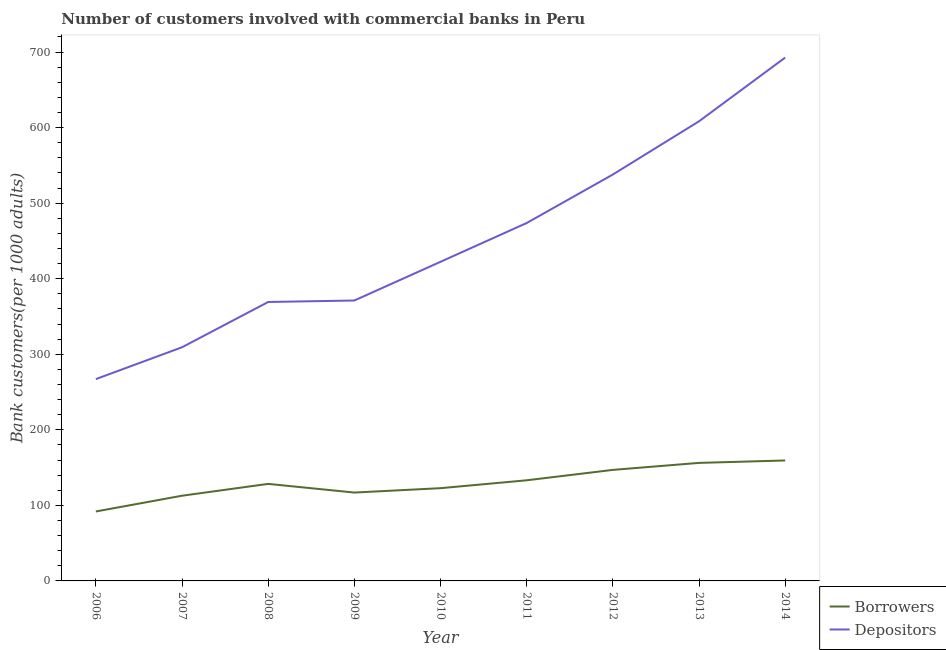How many different coloured lines are there?
Your answer should be very brief. 2. What is the number of borrowers in 2009?
Ensure brevity in your answer.  116.95. Across all years, what is the maximum number of borrowers?
Provide a short and direct response. 159.42. Across all years, what is the minimum number of borrowers?
Your response must be concise. 91.92. In which year was the number of depositors maximum?
Ensure brevity in your answer.  2014. What is the total number of depositors in the graph?
Provide a short and direct response. 4051.47. What is the difference between the number of borrowers in 2008 and that in 2009?
Keep it short and to the point. 11.47. What is the difference between the number of depositors in 2006 and the number of borrowers in 2012?
Keep it short and to the point. 120.16. What is the average number of borrowers per year?
Your answer should be compact. 129.84. In the year 2012, what is the difference between the number of borrowers and number of depositors?
Your answer should be compact. -390.93. In how many years, is the number of borrowers greater than 560?
Ensure brevity in your answer.  0. What is the ratio of the number of depositors in 2006 to that in 2014?
Provide a succinct answer. 0.39. What is the difference between the highest and the second highest number of borrowers?
Provide a short and direct response. 3.21. What is the difference between the highest and the lowest number of depositors?
Make the answer very short. 425.54. Is the sum of the number of borrowers in 2011 and 2013 greater than the maximum number of depositors across all years?
Provide a succinct answer. No. How many lines are there?
Your answer should be very brief. 2. How many years are there in the graph?
Offer a very short reply. 9. What is the difference between two consecutive major ticks on the Y-axis?
Offer a terse response. 100. Does the graph contain any zero values?
Your response must be concise. No. Where does the legend appear in the graph?
Your response must be concise. Bottom right. How many legend labels are there?
Provide a short and direct response. 2. What is the title of the graph?
Provide a succinct answer. Number of customers involved with commercial banks in Peru. Does "Lower secondary education" appear as one of the legend labels in the graph?
Your response must be concise. No. What is the label or title of the X-axis?
Give a very brief answer. Year. What is the label or title of the Y-axis?
Keep it short and to the point. Bank customers(per 1000 adults). What is the Bank customers(per 1000 adults) of Borrowers in 2006?
Your answer should be very brief. 91.92. What is the Bank customers(per 1000 adults) of Depositors in 2006?
Make the answer very short. 267.1. What is the Bank customers(per 1000 adults) of Borrowers in 2007?
Offer a terse response. 112.76. What is the Bank customers(per 1000 adults) of Depositors in 2007?
Offer a terse response. 309.23. What is the Bank customers(per 1000 adults) in Borrowers in 2008?
Give a very brief answer. 128.42. What is the Bank customers(per 1000 adults) in Depositors in 2008?
Your answer should be very brief. 369.17. What is the Bank customers(per 1000 adults) of Borrowers in 2009?
Offer a very short reply. 116.95. What is the Bank customers(per 1000 adults) of Depositors in 2009?
Your answer should be very brief. 371.13. What is the Bank customers(per 1000 adults) of Borrowers in 2010?
Offer a very short reply. 122.75. What is the Bank customers(per 1000 adults) of Depositors in 2010?
Ensure brevity in your answer.  422.34. What is the Bank customers(per 1000 adults) in Borrowers in 2011?
Offer a very short reply. 133.19. What is the Bank customers(per 1000 adults) in Depositors in 2011?
Your answer should be compact. 473.69. What is the Bank customers(per 1000 adults) in Borrowers in 2012?
Provide a short and direct response. 146.94. What is the Bank customers(per 1000 adults) of Depositors in 2012?
Your response must be concise. 537.87. What is the Bank customers(per 1000 adults) of Borrowers in 2013?
Offer a terse response. 156.21. What is the Bank customers(per 1000 adults) of Depositors in 2013?
Offer a terse response. 608.29. What is the Bank customers(per 1000 adults) of Borrowers in 2014?
Make the answer very short. 159.42. What is the Bank customers(per 1000 adults) of Depositors in 2014?
Provide a succinct answer. 692.64. Across all years, what is the maximum Bank customers(per 1000 adults) of Borrowers?
Provide a succinct answer. 159.42. Across all years, what is the maximum Bank customers(per 1000 adults) in Depositors?
Ensure brevity in your answer.  692.64. Across all years, what is the minimum Bank customers(per 1000 adults) in Borrowers?
Your answer should be very brief. 91.92. Across all years, what is the minimum Bank customers(per 1000 adults) of Depositors?
Make the answer very short. 267.1. What is the total Bank customers(per 1000 adults) in Borrowers in the graph?
Keep it short and to the point. 1168.57. What is the total Bank customers(per 1000 adults) in Depositors in the graph?
Your answer should be compact. 4051.47. What is the difference between the Bank customers(per 1000 adults) of Borrowers in 2006 and that in 2007?
Offer a terse response. -20.84. What is the difference between the Bank customers(per 1000 adults) in Depositors in 2006 and that in 2007?
Give a very brief answer. -42.13. What is the difference between the Bank customers(per 1000 adults) in Borrowers in 2006 and that in 2008?
Your answer should be compact. -36.5. What is the difference between the Bank customers(per 1000 adults) of Depositors in 2006 and that in 2008?
Your answer should be compact. -102.07. What is the difference between the Bank customers(per 1000 adults) in Borrowers in 2006 and that in 2009?
Keep it short and to the point. -25.03. What is the difference between the Bank customers(per 1000 adults) of Depositors in 2006 and that in 2009?
Provide a succinct answer. -104.03. What is the difference between the Bank customers(per 1000 adults) in Borrowers in 2006 and that in 2010?
Ensure brevity in your answer.  -30.83. What is the difference between the Bank customers(per 1000 adults) in Depositors in 2006 and that in 2010?
Keep it short and to the point. -155.24. What is the difference between the Bank customers(per 1000 adults) of Borrowers in 2006 and that in 2011?
Your answer should be compact. -41.26. What is the difference between the Bank customers(per 1000 adults) of Depositors in 2006 and that in 2011?
Your response must be concise. -206.59. What is the difference between the Bank customers(per 1000 adults) in Borrowers in 2006 and that in 2012?
Provide a succinct answer. -55.02. What is the difference between the Bank customers(per 1000 adults) of Depositors in 2006 and that in 2012?
Ensure brevity in your answer.  -270.77. What is the difference between the Bank customers(per 1000 adults) of Borrowers in 2006 and that in 2013?
Your answer should be compact. -64.29. What is the difference between the Bank customers(per 1000 adults) in Depositors in 2006 and that in 2013?
Offer a terse response. -341.19. What is the difference between the Bank customers(per 1000 adults) in Borrowers in 2006 and that in 2014?
Provide a succinct answer. -67.49. What is the difference between the Bank customers(per 1000 adults) in Depositors in 2006 and that in 2014?
Your response must be concise. -425.54. What is the difference between the Bank customers(per 1000 adults) in Borrowers in 2007 and that in 2008?
Provide a short and direct response. -15.66. What is the difference between the Bank customers(per 1000 adults) in Depositors in 2007 and that in 2008?
Your answer should be compact. -59.93. What is the difference between the Bank customers(per 1000 adults) of Borrowers in 2007 and that in 2009?
Your answer should be compact. -4.19. What is the difference between the Bank customers(per 1000 adults) in Depositors in 2007 and that in 2009?
Provide a succinct answer. -61.9. What is the difference between the Bank customers(per 1000 adults) of Borrowers in 2007 and that in 2010?
Offer a very short reply. -9.99. What is the difference between the Bank customers(per 1000 adults) of Depositors in 2007 and that in 2010?
Make the answer very short. -113.11. What is the difference between the Bank customers(per 1000 adults) in Borrowers in 2007 and that in 2011?
Make the answer very short. -20.42. What is the difference between the Bank customers(per 1000 adults) of Depositors in 2007 and that in 2011?
Offer a very short reply. -164.46. What is the difference between the Bank customers(per 1000 adults) in Borrowers in 2007 and that in 2012?
Ensure brevity in your answer.  -34.18. What is the difference between the Bank customers(per 1000 adults) in Depositors in 2007 and that in 2012?
Offer a terse response. -228.64. What is the difference between the Bank customers(per 1000 adults) of Borrowers in 2007 and that in 2013?
Give a very brief answer. -43.45. What is the difference between the Bank customers(per 1000 adults) of Depositors in 2007 and that in 2013?
Offer a terse response. -299.06. What is the difference between the Bank customers(per 1000 adults) in Borrowers in 2007 and that in 2014?
Offer a very short reply. -46.65. What is the difference between the Bank customers(per 1000 adults) of Depositors in 2007 and that in 2014?
Ensure brevity in your answer.  -383.41. What is the difference between the Bank customers(per 1000 adults) of Borrowers in 2008 and that in 2009?
Your answer should be compact. 11.47. What is the difference between the Bank customers(per 1000 adults) of Depositors in 2008 and that in 2009?
Offer a terse response. -1.97. What is the difference between the Bank customers(per 1000 adults) of Borrowers in 2008 and that in 2010?
Offer a terse response. 5.67. What is the difference between the Bank customers(per 1000 adults) of Depositors in 2008 and that in 2010?
Make the answer very short. -53.18. What is the difference between the Bank customers(per 1000 adults) in Borrowers in 2008 and that in 2011?
Provide a succinct answer. -4.77. What is the difference between the Bank customers(per 1000 adults) of Depositors in 2008 and that in 2011?
Make the answer very short. -104.52. What is the difference between the Bank customers(per 1000 adults) of Borrowers in 2008 and that in 2012?
Your answer should be compact. -18.52. What is the difference between the Bank customers(per 1000 adults) of Depositors in 2008 and that in 2012?
Give a very brief answer. -168.7. What is the difference between the Bank customers(per 1000 adults) of Borrowers in 2008 and that in 2013?
Give a very brief answer. -27.79. What is the difference between the Bank customers(per 1000 adults) in Depositors in 2008 and that in 2013?
Your answer should be very brief. -239.12. What is the difference between the Bank customers(per 1000 adults) of Borrowers in 2008 and that in 2014?
Your answer should be compact. -31. What is the difference between the Bank customers(per 1000 adults) of Depositors in 2008 and that in 2014?
Your answer should be compact. -323.48. What is the difference between the Bank customers(per 1000 adults) of Borrowers in 2009 and that in 2010?
Make the answer very short. -5.8. What is the difference between the Bank customers(per 1000 adults) in Depositors in 2009 and that in 2010?
Your answer should be compact. -51.21. What is the difference between the Bank customers(per 1000 adults) in Borrowers in 2009 and that in 2011?
Your response must be concise. -16.24. What is the difference between the Bank customers(per 1000 adults) of Depositors in 2009 and that in 2011?
Make the answer very short. -102.56. What is the difference between the Bank customers(per 1000 adults) in Borrowers in 2009 and that in 2012?
Ensure brevity in your answer.  -29.99. What is the difference between the Bank customers(per 1000 adults) in Depositors in 2009 and that in 2012?
Your answer should be compact. -166.74. What is the difference between the Bank customers(per 1000 adults) in Borrowers in 2009 and that in 2013?
Keep it short and to the point. -39.26. What is the difference between the Bank customers(per 1000 adults) of Depositors in 2009 and that in 2013?
Your response must be concise. -237.16. What is the difference between the Bank customers(per 1000 adults) in Borrowers in 2009 and that in 2014?
Offer a very short reply. -42.47. What is the difference between the Bank customers(per 1000 adults) of Depositors in 2009 and that in 2014?
Make the answer very short. -321.51. What is the difference between the Bank customers(per 1000 adults) in Borrowers in 2010 and that in 2011?
Your answer should be very brief. -10.43. What is the difference between the Bank customers(per 1000 adults) of Depositors in 2010 and that in 2011?
Keep it short and to the point. -51.35. What is the difference between the Bank customers(per 1000 adults) of Borrowers in 2010 and that in 2012?
Make the answer very short. -24.19. What is the difference between the Bank customers(per 1000 adults) in Depositors in 2010 and that in 2012?
Provide a succinct answer. -115.53. What is the difference between the Bank customers(per 1000 adults) of Borrowers in 2010 and that in 2013?
Offer a very short reply. -33.46. What is the difference between the Bank customers(per 1000 adults) in Depositors in 2010 and that in 2013?
Make the answer very short. -185.95. What is the difference between the Bank customers(per 1000 adults) in Borrowers in 2010 and that in 2014?
Ensure brevity in your answer.  -36.66. What is the difference between the Bank customers(per 1000 adults) in Depositors in 2010 and that in 2014?
Provide a short and direct response. -270.3. What is the difference between the Bank customers(per 1000 adults) in Borrowers in 2011 and that in 2012?
Your response must be concise. -13.75. What is the difference between the Bank customers(per 1000 adults) in Depositors in 2011 and that in 2012?
Make the answer very short. -64.18. What is the difference between the Bank customers(per 1000 adults) in Borrowers in 2011 and that in 2013?
Give a very brief answer. -23.02. What is the difference between the Bank customers(per 1000 adults) in Depositors in 2011 and that in 2013?
Give a very brief answer. -134.6. What is the difference between the Bank customers(per 1000 adults) in Borrowers in 2011 and that in 2014?
Make the answer very short. -26.23. What is the difference between the Bank customers(per 1000 adults) of Depositors in 2011 and that in 2014?
Your response must be concise. -218.95. What is the difference between the Bank customers(per 1000 adults) of Borrowers in 2012 and that in 2013?
Ensure brevity in your answer.  -9.27. What is the difference between the Bank customers(per 1000 adults) in Depositors in 2012 and that in 2013?
Your answer should be very brief. -70.42. What is the difference between the Bank customers(per 1000 adults) in Borrowers in 2012 and that in 2014?
Provide a succinct answer. -12.48. What is the difference between the Bank customers(per 1000 adults) of Depositors in 2012 and that in 2014?
Keep it short and to the point. -154.77. What is the difference between the Bank customers(per 1000 adults) of Borrowers in 2013 and that in 2014?
Keep it short and to the point. -3.21. What is the difference between the Bank customers(per 1000 adults) in Depositors in 2013 and that in 2014?
Your answer should be very brief. -84.35. What is the difference between the Bank customers(per 1000 adults) of Borrowers in 2006 and the Bank customers(per 1000 adults) of Depositors in 2007?
Ensure brevity in your answer.  -217.31. What is the difference between the Bank customers(per 1000 adults) in Borrowers in 2006 and the Bank customers(per 1000 adults) in Depositors in 2008?
Your answer should be compact. -277.24. What is the difference between the Bank customers(per 1000 adults) of Borrowers in 2006 and the Bank customers(per 1000 adults) of Depositors in 2009?
Keep it short and to the point. -279.21. What is the difference between the Bank customers(per 1000 adults) in Borrowers in 2006 and the Bank customers(per 1000 adults) in Depositors in 2010?
Your answer should be very brief. -330.42. What is the difference between the Bank customers(per 1000 adults) in Borrowers in 2006 and the Bank customers(per 1000 adults) in Depositors in 2011?
Keep it short and to the point. -381.76. What is the difference between the Bank customers(per 1000 adults) of Borrowers in 2006 and the Bank customers(per 1000 adults) of Depositors in 2012?
Ensure brevity in your answer.  -445.95. What is the difference between the Bank customers(per 1000 adults) of Borrowers in 2006 and the Bank customers(per 1000 adults) of Depositors in 2013?
Offer a very short reply. -516.37. What is the difference between the Bank customers(per 1000 adults) of Borrowers in 2006 and the Bank customers(per 1000 adults) of Depositors in 2014?
Make the answer very short. -600.72. What is the difference between the Bank customers(per 1000 adults) of Borrowers in 2007 and the Bank customers(per 1000 adults) of Depositors in 2008?
Your response must be concise. -256.4. What is the difference between the Bank customers(per 1000 adults) in Borrowers in 2007 and the Bank customers(per 1000 adults) in Depositors in 2009?
Your answer should be very brief. -258.37. What is the difference between the Bank customers(per 1000 adults) of Borrowers in 2007 and the Bank customers(per 1000 adults) of Depositors in 2010?
Give a very brief answer. -309.58. What is the difference between the Bank customers(per 1000 adults) in Borrowers in 2007 and the Bank customers(per 1000 adults) in Depositors in 2011?
Provide a succinct answer. -360.93. What is the difference between the Bank customers(per 1000 adults) in Borrowers in 2007 and the Bank customers(per 1000 adults) in Depositors in 2012?
Your response must be concise. -425.11. What is the difference between the Bank customers(per 1000 adults) of Borrowers in 2007 and the Bank customers(per 1000 adults) of Depositors in 2013?
Provide a short and direct response. -495.53. What is the difference between the Bank customers(per 1000 adults) in Borrowers in 2007 and the Bank customers(per 1000 adults) in Depositors in 2014?
Offer a very short reply. -579.88. What is the difference between the Bank customers(per 1000 adults) in Borrowers in 2008 and the Bank customers(per 1000 adults) in Depositors in 2009?
Your answer should be compact. -242.71. What is the difference between the Bank customers(per 1000 adults) in Borrowers in 2008 and the Bank customers(per 1000 adults) in Depositors in 2010?
Provide a succinct answer. -293.92. What is the difference between the Bank customers(per 1000 adults) of Borrowers in 2008 and the Bank customers(per 1000 adults) of Depositors in 2011?
Provide a short and direct response. -345.27. What is the difference between the Bank customers(per 1000 adults) in Borrowers in 2008 and the Bank customers(per 1000 adults) in Depositors in 2012?
Provide a succinct answer. -409.45. What is the difference between the Bank customers(per 1000 adults) in Borrowers in 2008 and the Bank customers(per 1000 adults) in Depositors in 2013?
Provide a short and direct response. -479.87. What is the difference between the Bank customers(per 1000 adults) in Borrowers in 2008 and the Bank customers(per 1000 adults) in Depositors in 2014?
Keep it short and to the point. -564.22. What is the difference between the Bank customers(per 1000 adults) in Borrowers in 2009 and the Bank customers(per 1000 adults) in Depositors in 2010?
Provide a short and direct response. -305.39. What is the difference between the Bank customers(per 1000 adults) in Borrowers in 2009 and the Bank customers(per 1000 adults) in Depositors in 2011?
Your answer should be compact. -356.74. What is the difference between the Bank customers(per 1000 adults) in Borrowers in 2009 and the Bank customers(per 1000 adults) in Depositors in 2012?
Ensure brevity in your answer.  -420.92. What is the difference between the Bank customers(per 1000 adults) in Borrowers in 2009 and the Bank customers(per 1000 adults) in Depositors in 2013?
Ensure brevity in your answer.  -491.34. What is the difference between the Bank customers(per 1000 adults) in Borrowers in 2009 and the Bank customers(per 1000 adults) in Depositors in 2014?
Offer a terse response. -575.69. What is the difference between the Bank customers(per 1000 adults) in Borrowers in 2010 and the Bank customers(per 1000 adults) in Depositors in 2011?
Provide a short and direct response. -350.94. What is the difference between the Bank customers(per 1000 adults) of Borrowers in 2010 and the Bank customers(per 1000 adults) of Depositors in 2012?
Make the answer very short. -415.12. What is the difference between the Bank customers(per 1000 adults) of Borrowers in 2010 and the Bank customers(per 1000 adults) of Depositors in 2013?
Offer a terse response. -485.54. What is the difference between the Bank customers(per 1000 adults) in Borrowers in 2010 and the Bank customers(per 1000 adults) in Depositors in 2014?
Your answer should be compact. -569.89. What is the difference between the Bank customers(per 1000 adults) in Borrowers in 2011 and the Bank customers(per 1000 adults) in Depositors in 2012?
Ensure brevity in your answer.  -404.68. What is the difference between the Bank customers(per 1000 adults) in Borrowers in 2011 and the Bank customers(per 1000 adults) in Depositors in 2013?
Provide a succinct answer. -475.1. What is the difference between the Bank customers(per 1000 adults) in Borrowers in 2011 and the Bank customers(per 1000 adults) in Depositors in 2014?
Keep it short and to the point. -559.46. What is the difference between the Bank customers(per 1000 adults) of Borrowers in 2012 and the Bank customers(per 1000 adults) of Depositors in 2013?
Keep it short and to the point. -461.35. What is the difference between the Bank customers(per 1000 adults) of Borrowers in 2012 and the Bank customers(per 1000 adults) of Depositors in 2014?
Your response must be concise. -545.7. What is the difference between the Bank customers(per 1000 adults) of Borrowers in 2013 and the Bank customers(per 1000 adults) of Depositors in 2014?
Make the answer very short. -536.43. What is the average Bank customers(per 1000 adults) of Borrowers per year?
Offer a terse response. 129.84. What is the average Bank customers(per 1000 adults) in Depositors per year?
Your answer should be compact. 450.16. In the year 2006, what is the difference between the Bank customers(per 1000 adults) of Borrowers and Bank customers(per 1000 adults) of Depositors?
Make the answer very short. -175.18. In the year 2007, what is the difference between the Bank customers(per 1000 adults) of Borrowers and Bank customers(per 1000 adults) of Depositors?
Your answer should be very brief. -196.47. In the year 2008, what is the difference between the Bank customers(per 1000 adults) in Borrowers and Bank customers(per 1000 adults) in Depositors?
Ensure brevity in your answer.  -240.75. In the year 2009, what is the difference between the Bank customers(per 1000 adults) of Borrowers and Bank customers(per 1000 adults) of Depositors?
Offer a terse response. -254.18. In the year 2010, what is the difference between the Bank customers(per 1000 adults) in Borrowers and Bank customers(per 1000 adults) in Depositors?
Your answer should be very brief. -299.59. In the year 2011, what is the difference between the Bank customers(per 1000 adults) in Borrowers and Bank customers(per 1000 adults) in Depositors?
Give a very brief answer. -340.5. In the year 2012, what is the difference between the Bank customers(per 1000 adults) in Borrowers and Bank customers(per 1000 adults) in Depositors?
Your response must be concise. -390.93. In the year 2013, what is the difference between the Bank customers(per 1000 adults) in Borrowers and Bank customers(per 1000 adults) in Depositors?
Make the answer very short. -452.08. In the year 2014, what is the difference between the Bank customers(per 1000 adults) of Borrowers and Bank customers(per 1000 adults) of Depositors?
Provide a succinct answer. -533.23. What is the ratio of the Bank customers(per 1000 adults) of Borrowers in 2006 to that in 2007?
Provide a short and direct response. 0.82. What is the ratio of the Bank customers(per 1000 adults) of Depositors in 2006 to that in 2007?
Your answer should be very brief. 0.86. What is the ratio of the Bank customers(per 1000 adults) in Borrowers in 2006 to that in 2008?
Give a very brief answer. 0.72. What is the ratio of the Bank customers(per 1000 adults) of Depositors in 2006 to that in 2008?
Offer a terse response. 0.72. What is the ratio of the Bank customers(per 1000 adults) of Borrowers in 2006 to that in 2009?
Keep it short and to the point. 0.79. What is the ratio of the Bank customers(per 1000 adults) in Depositors in 2006 to that in 2009?
Provide a succinct answer. 0.72. What is the ratio of the Bank customers(per 1000 adults) of Borrowers in 2006 to that in 2010?
Your answer should be very brief. 0.75. What is the ratio of the Bank customers(per 1000 adults) in Depositors in 2006 to that in 2010?
Give a very brief answer. 0.63. What is the ratio of the Bank customers(per 1000 adults) of Borrowers in 2006 to that in 2011?
Give a very brief answer. 0.69. What is the ratio of the Bank customers(per 1000 adults) in Depositors in 2006 to that in 2011?
Ensure brevity in your answer.  0.56. What is the ratio of the Bank customers(per 1000 adults) of Borrowers in 2006 to that in 2012?
Provide a succinct answer. 0.63. What is the ratio of the Bank customers(per 1000 adults) in Depositors in 2006 to that in 2012?
Your response must be concise. 0.5. What is the ratio of the Bank customers(per 1000 adults) of Borrowers in 2006 to that in 2013?
Your answer should be compact. 0.59. What is the ratio of the Bank customers(per 1000 adults) of Depositors in 2006 to that in 2013?
Provide a short and direct response. 0.44. What is the ratio of the Bank customers(per 1000 adults) in Borrowers in 2006 to that in 2014?
Give a very brief answer. 0.58. What is the ratio of the Bank customers(per 1000 adults) in Depositors in 2006 to that in 2014?
Provide a short and direct response. 0.39. What is the ratio of the Bank customers(per 1000 adults) in Borrowers in 2007 to that in 2008?
Provide a succinct answer. 0.88. What is the ratio of the Bank customers(per 1000 adults) in Depositors in 2007 to that in 2008?
Keep it short and to the point. 0.84. What is the ratio of the Bank customers(per 1000 adults) of Borrowers in 2007 to that in 2009?
Ensure brevity in your answer.  0.96. What is the ratio of the Bank customers(per 1000 adults) of Depositors in 2007 to that in 2009?
Ensure brevity in your answer.  0.83. What is the ratio of the Bank customers(per 1000 adults) of Borrowers in 2007 to that in 2010?
Give a very brief answer. 0.92. What is the ratio of the Bank customers(per 1000 adults) of Depositors in 2007 to that in 2010?
Offer a very short reply. 0.73. What is the ratio of the Bank customers(per 1000 adults) in Borrowers in 2007 to that in 2011?
Your answer should be very brief. 0.85. What is the ratio of the Bank customers(per 1000 adults) of Depositors in 2007 to that in 2011?
Provide a succinct answer. 0.65. What is the ratio of the Bank customers(per 1000 adults) of Borrowers in 2007 to that in 2012?
Your answer should be very brief. 0.77. What is the ratio of the Bank customers(per 1000 adults) of Depositors in 2007 to that in 2012?
Your answer should be compact. 0.57. What is the ratio of the Bank customers(per 1000 adults) of Borrowers in 2007 to that in 2013?
Your answer should be very brief. 0.72. What is the ratio of the Bank customers(per 1000 adults) of Depositors in 2007 to that in 2013?
Offer a very short reply. 0.51. What is the ratio of the Bank customers(per 1000 adults) of Borrowers in 2007 to that in 2014?
Your response must be concise. 0.71. What is the ratio of the Bank customers(per 1000 adults) of Depositors in 2007 to that in 2014?
Offer a very short reply. 0.45. What is the ratio of the Bank customers(per 1000 adults) in Borrowers in 2008 to that in 2009?
Provide a short and direct response. 1.1. What is the ratio of the Bank customers(per 1000 adults) of Depositors in 2008 to that in 2009?
Give a very brief answer. 0.99. What is the ratio of the Bank customers(per 1000 adults) of Borrowers in 2008 to that in 2010?
Provide a short and direct response. 1.05. What is the ratio of the Bank customers(per 1000 adults) in Depositors in 2008 to that in 2010?
Keep it short and to the point. 0.87. What is the ratio of the Bank customers(per 1000 adults) of Borrowers in 2008 to that in 2011?
Give a very brief answer. 0.96. What is the ratio of the Bank customers(per 1000 adults) in Depositors in 2008 to that in 2011?
Provide a short and direct response. 0.78. What is the ratio of the Bank customers(per 1000 adults) in Borrowers in 2008 to that in 2012?
Offer a very short reply. 0.87. What is the ratio of the Bank customers(per 1000 adults) of Depositors in 2008 to that in 2012?
Provide a succinct answer. 0.69. What is the ratio of the Bank customers(per 1000 adults) in Borrowers in 2008 to that in 2013?
Your answer should be compact. 0.82. What is the ratio of the Bank customers(per 1000 adults) in Depositors in 2008 to that in 2013?
Ensure brevity in your answer.  0.61. What is the ratio of the Bank customers(per 1000 adults) in Borrowers in 2008 to that in 2014?
Offer a very short reply. 0.81. What is the ratio of the Bank customers(per 1000 adults) in Depositors in 2008 to that in 2014?
Your answer should be very brief. 0.53. What is the ratio of the Bank customers(per 1000 adults) of Borrowers in 2009 to that in 2010?
Offer a terse response. 0.95. What is the ratio of the Bank customers(per 1000 adults) of Depositors in 2009 to that in 2010?
Offer a terse response. 0.88. What is the ratio of the Bank customers(per 1000 adults) in Borrowers in 2009 to that in 2011?
Your response must be concise. 0.88. What is the ratio of the Bank customers(per 1000 adults) in Depositors in 2009 to that in 2011?
Your answer should be very brief. 0.78. What is the ratio of the Bank customers(per 1000 adults) in Borrowers in 2009 to that in 2012?
Offer a terse response. 0.8. What is the ratio of the Bank customers(per 1000 adults) of Depositors in 2009 to that in 2012?
Your answer should be compact. 0.69. What is the ratio of the Bank customers(per 1000 adults) of Borrowers in 2009 to that in 2013?
Offer a very short reply. 0.75. What is the ratio of the Bank customers(per 1000 adults) of Depositors in 2009 to that in 2013?
Your answer should be compact. 0.61. What is the ratio of the Bank customers(per 1000 adults) of Borrowers in 2009 to that in 2014?
Offer a very short reply. 0.73. What is the ratio of the Bank customers(per 1000 adults) of Depositors in 2009 to that in 2014?
Ensure brevity in your answer.  0.54. What is the ratio of the Bank customers(per 1000 adults) in Borrowers in 2010 to that in 2011?
Offer a terse response. 0.92. What is the ratio of the Bank customers(per 1000 adults) in Depositors in 2010 to that in 2011?
Provide a succinct answer. 0.89. What is the ratio of the Bank customers(per 1000 adults) of Borrowers in 2010 to that in 2012?
Your response must be concise. 0.84. What is the ratio of the Bank customers(per 1000 adults) of Depositors in 2010 to that in 2012?
Provide a succinct answer. 0.79. What is the ratio of the Bank customers(per 1000 adults) of Borrowers in 2010 to that in 2013?
Offer a very short reply. 0.79. What is the ratio of the Bank customers(per 1000 adults) in Depositors in 2010 to that in 2013?
Ensure brevity in your answer.  0.69. What is the ratio of the Bank customers(per 1000 adults) of Borrowers in 2010 to that in 2014?
Your answer should be very brief. 0.77. What is the ratio of the Bank customers(per 1000 adults) in Depositors in 2010 to that in 2014?
Your answer should be compact. 0.61. What is the ratio of the Bank customers(per 1000 adults) in Borrowers in 2011 to that in 2012?
Keep it short and to the point. 0.91. What is the ratio of the Bank customers(per 1000 adults) in Depositors in 2011 to that in 2012?
Your answer should be compact. 0.88. What is the ratio of the Bank customers(per 1000 adults) of Borrowers in 2011 to that in 2013?
Give a very brief answer. 0.85. What is the ratio of the Bank customers(per 1000 adults) in Depositors in 2011 to that in 2013?
Keep it short and to the point. 0.78. What is the ratio of the Bank customers(per 1000 adults) in Borrowers in 2011 to that in 2014?
Provide a succinct answer. 0.84. What is the ratio of the Bank customers(per 1000 adults) of Depositors in 2011 to that in 2014?
Your answer should be compact. 0.68. What is the ratio of the Bank customers(per 1000 adults) of Borrowers in 2012 to that in 2013?
Keep it short and to the point. 0.94. What is the ratio of the Bank customers(per 1000 adults) of Depositors in 2012 to that in 2013?
Your response must be concise. 0.88. What is the ratio of the Bank customers(per 1000 adults) of Borrowers in 2012 to that in 2014?
Offer a terse response. 0.92. What is the ratio of the Bank customers(per 1000 adults) in Depositors in 2012 to that in 2014?
Give a very brief answer. 0.78. What is the ratio of the Bank customers(per 1000 adults) of Borrowers in 2013 to that in 2014?
Keep it short and to the point. 0.98. What is the ratio of the Bank customers(per 1000 adults) in Depositors in 2013 to that in 2014?
Offer a terse response. 0.88. What is the difference between the highest and the second highest Bank customers(per 1000 adults) of Borrowers?
Give a very brief answer. 3.21. What is the difference between the highest and the second highest Bank customers(per 1000 adults) of Depositors?
Your response must be concise. 84.35. What is the difference between the highest and the lowest Bank customers(per 1000 adults) in Borrowers?
Make the answer very short. 67.49. What is the difference between the highest and the lowest Bank customers(per 1000 adults) in Depositors?
Offer a very short reply. 425.54. 